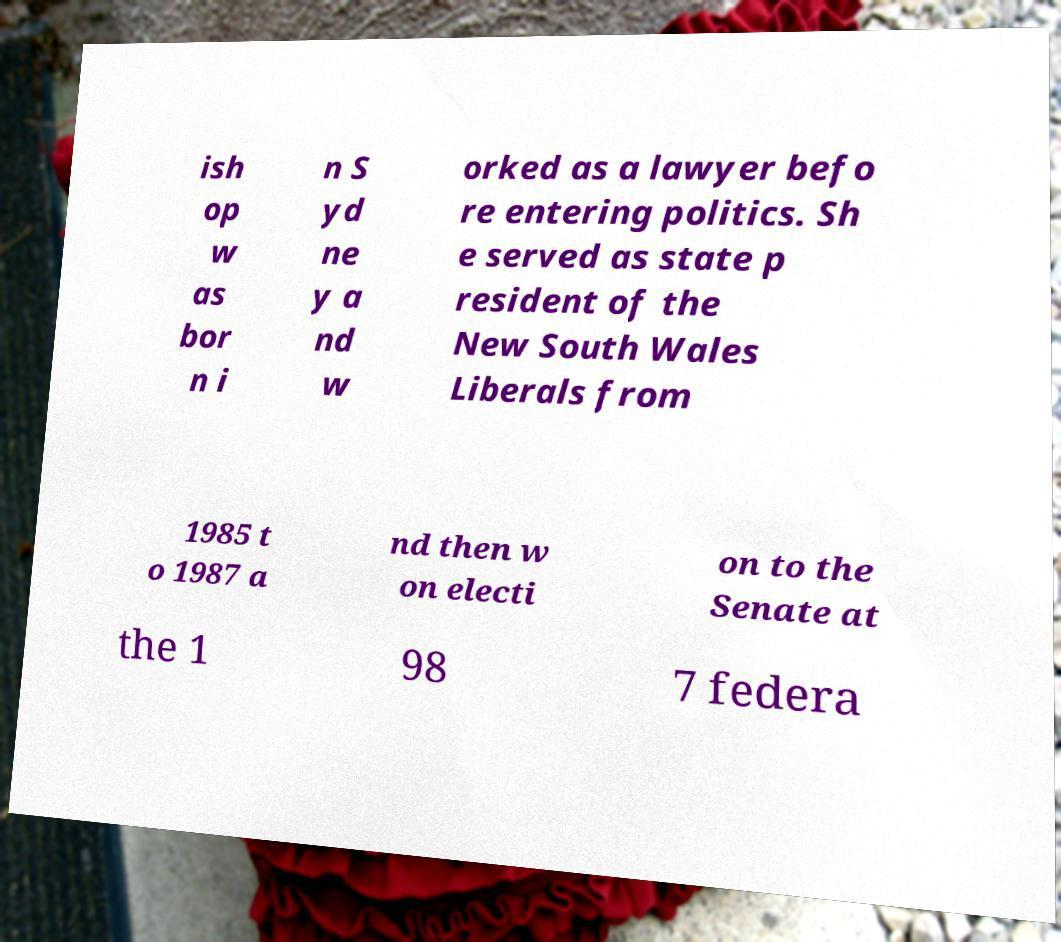For documentation purposes, I need the text within this image transcribed. Could you provide that? ish op w as bor n i n S yd ne y a nd w orked as a lawyer befo re entering politics. Sh e served as state p resident of the New South Wales Liberals from 1985 t o 1987 a nd then w on electi on to the Senate at the 1 98 7 federa 